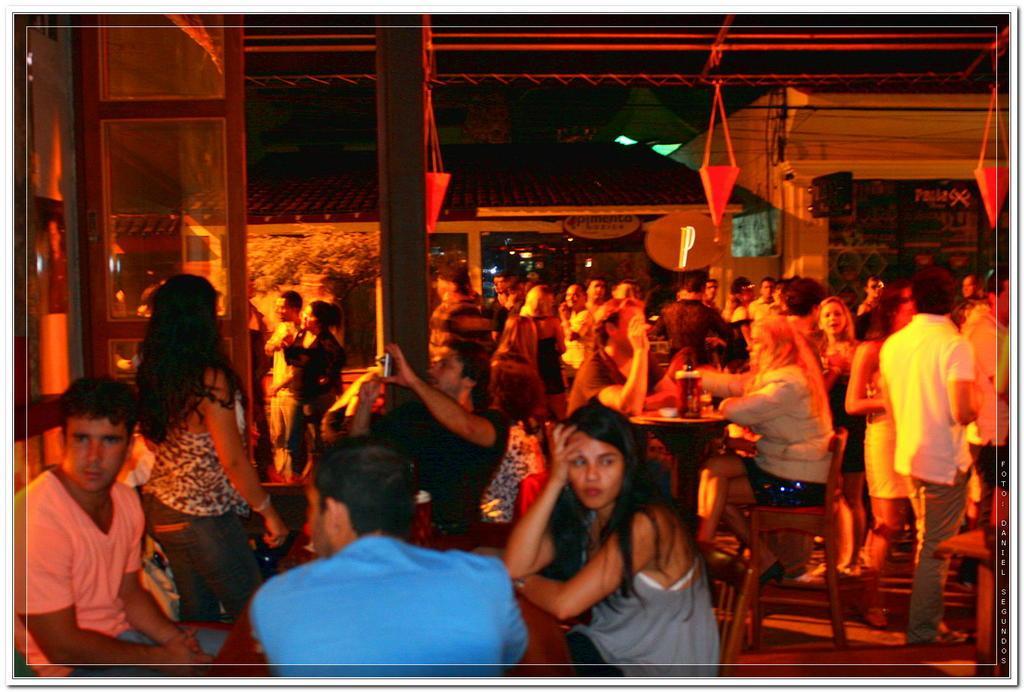Could you give a brief overview of what you see in this image? In this image we can see many people. Some are sitting on chairs. And we can see decorations. In the back there are buildings. And there are lights. 